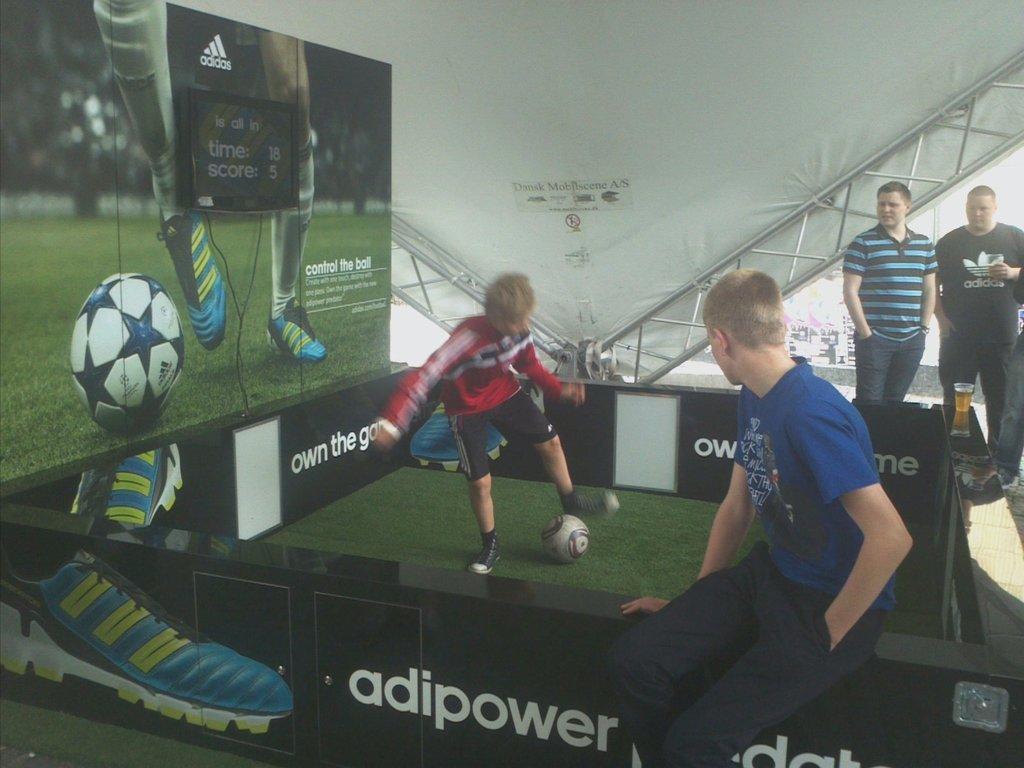Describe this image in one or two sentences. here is a boy playing football. This person is sitting. I can see a beer glass placed on this. There are two persons standing and looking at the boy. This looks like a banner where a scoreboard is attached to it. 